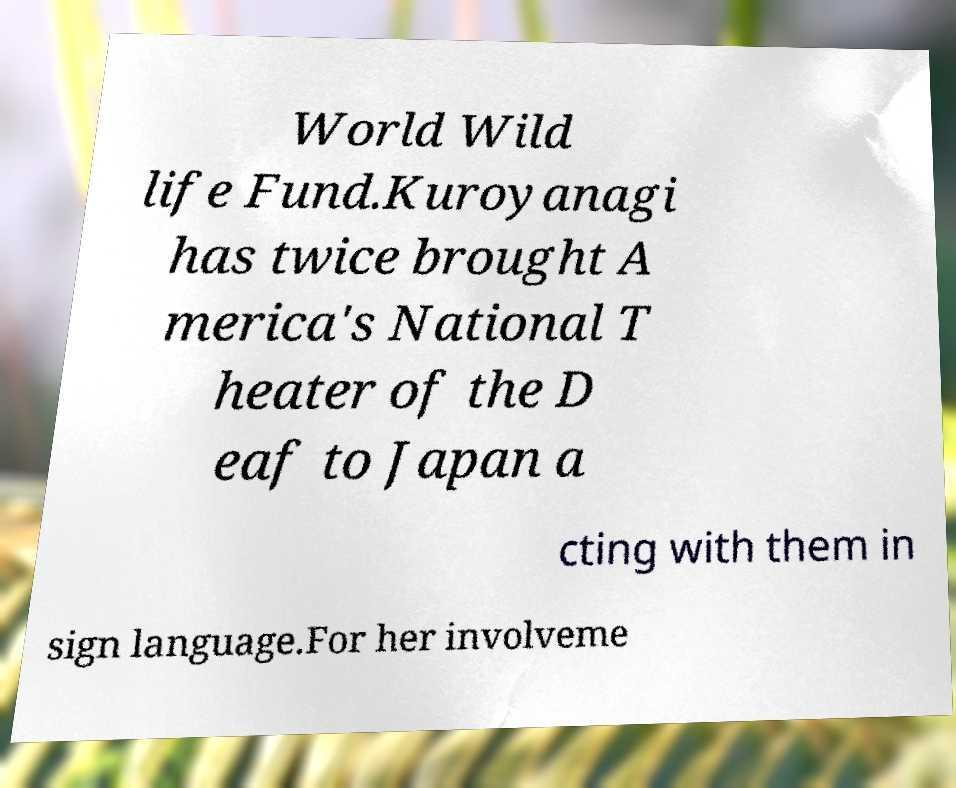Could you assist in decoding the text presented in this image and type it out clearly? World Wild life Fund.Kuroyanagi has twice brought A merica's National T heater of the D eaf to Japan a cting with them in sign language.For her involveme 